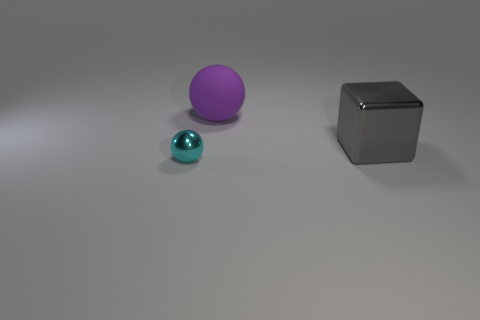Add 2 tiny red rubber objects. How many objects exist? 5 Subtract all blocks. How many objects are left? 2 Add 2 gray metal things. How many gray metal things are left? 3 Add 2 big purple things. How many big purple things exist? 3 Subtract 0 yellow cylinders. How many objects are left? 3 Subtract all metallic cubes. Subtract all rubber objects. How many objects are left? 1 